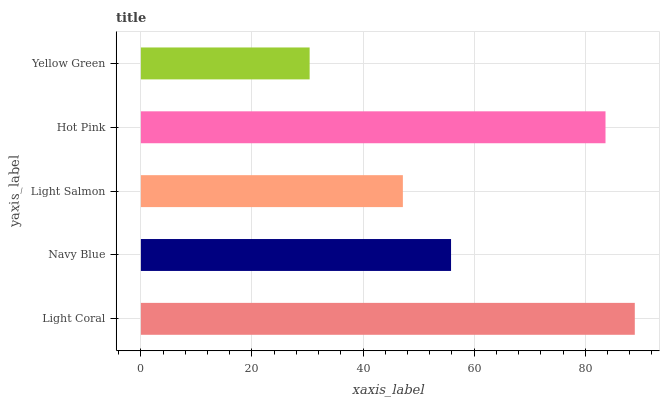Is Yellow Green the minimum?
Answer yes or no. Yes. Is Light Coral the maximum?
Answer yes or no. Yes. Is Navy Blue the minimum?
Answer yes or no. No. Is Navy Blue the maximum?
Answer yes or no. No. Is Light Coral greater than Navy Blue?
Answer yes or no. Yes. Is Navy Blue less than Light Coral?
Answer yes or no. Yes. Is Navy Blue greater than Light Coral?
Answer yes or no. No. Is Light Coral less than Navy Blue?
Answer yes or no. No. Is Navy Blue the high median?
Answer yes or no. Yes. Is Navy Blue the low median?
Answer yes or no. Yes. Is Light Coral the high median?
Answer yes or no. No. Is Light Salmon the low median?
Answer yes or no. No. 